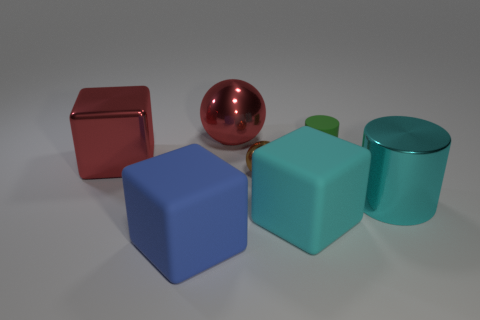Is the number of red things less than the number of small gray rubber blocks?
Make the answer very short. No. Does the cyan block have the same size as the sphere on the left side of the brown ball?
Ensure brevity in your answer.  Yes. Are there any other things that have the same shape as the brown metallic thing?
Offer a very short reply. Yes. What size is the brown metallic ball?
Offer a terse response. Small. Is the number of brown spheres that are in front of the cyan shiny cylinder less than the number of large yellow cylinders?
Provide a short and direct response. No. Is the size of the cyan rubber block the same as the blue cube?
Your answer should be compact. Yes. What color is the large ball that is made of the same material as the red cube?
Provide a succinct answer. Red. Are there fewer shiny cubes that are on the right side of the green matte cylinder than spheres behind the shiny cylinder?
Ensure brevity in your answer.  Yes. What number of tiny rubber things have the same color as the large ball?
Provide a succinct answer. 0. There is a thing that is the same color as the large cylinder; what is it made of?
Your answer should be compact. Rubber. 